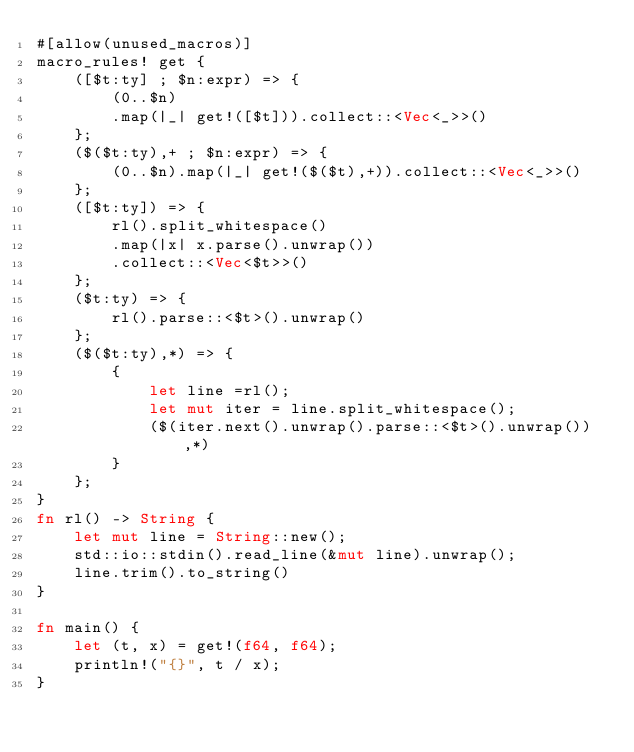<code> <loc_0><loc_0><loc_500><loc_500><_Rust_>#[allow(unused_macros)]
macro_rules! get {
    ([$t:ty] ; $n:expr) => {
        (0..$n)
        .map(|_| get!([$t])).collect::<Vec<_>>()
    };
    ($($t:ty),+ ; $n:expr) => {
        (0..$n).map(|_| get!($($t),+)).collect::<Vec<_>>()
    };
    ([$t:ty]) => {
        rl().split_whitespace()
        .map(|x| x.parse().unwrap())
        .collect::<Vec<$t>>()
    };
    ($t:ty) => {
        rl().parse::<$t>().unwrap()
    };
    ($($t:ty),*) => {
        {
            let line =rl();
            let mut iter = line.split_whitespace();
            ($(iter.next().unwrap().parse::<$t>().unwrap()),*)
        }
    };
}
fn rl() -> String {
    let mut line = String::new();
    std::io::stdin().read_line(&mut line).unwrap();
    line.trim().to_string()
}

fn main() {
    let (t, x) = get!(f64, f64);
    println!("{}", t / x);
}
</code> 